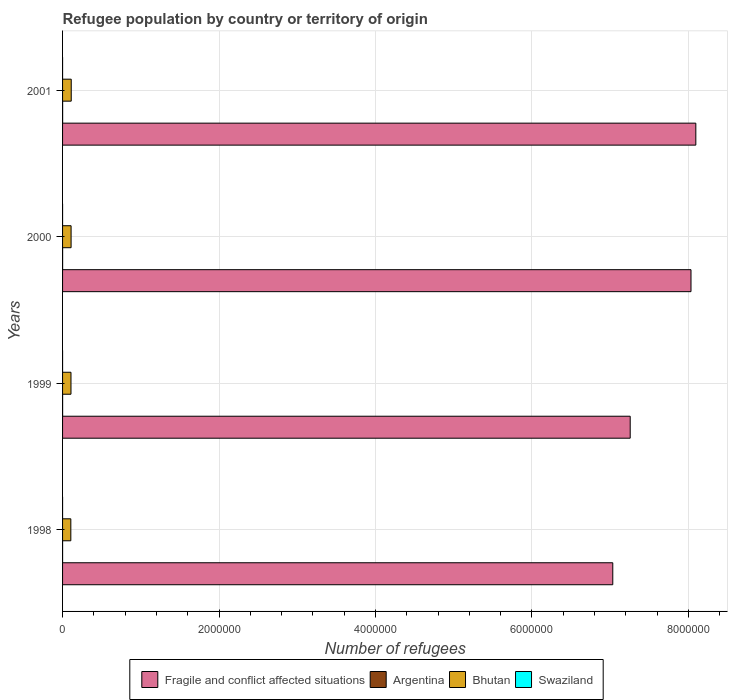How many different coloured bars are there?
Offer a very short reply. 4. Are the number of bars on each tick of the Y-axis equal?
Make the answer very short. Yes. How many bars are there on the 4th tick from the top?
Provide a short and direct response. 4. What is the label of the 4th group of bars from the top?
Make the answer very short. 1998. In how many cases, is the number of bars for a given year not equal to the number of legend labels?
Your answer should be compact. 0. What is the number of refugees in Fragile and conflict affected situations in 1998?
Offer a very short reply. 7.03e+06. Across all years, what is the maximum number of refugees in Bhutan?
Your response must be concise. 1.11e+05. Across all years, what is the minimum number of refugees in Argentina?
Keep it short and to the point. 142. In which year was the number of refugees in Argentina maximum?
Your response must be concise. 2001. In which year was the number of refugees in Argentina minimum?
Provide a short and direct response. 1998. What is the total number of refugees in Fragile and conflict affected situations in the graph?
Offer a terse response. 3.04e+07. What is the difference between the number of refugees in Argentina in 2000 and that in 2001?
Make the answer very short. -50. What is the difference between the number of refugees in Fragile and conflict affected situations in 2001 and the number of refugees in Argentina in 1999?
Ensure brevity in your answer.  8.09e+06. What is the average number of refugees in Bhutan per year?
Your answer should be very brief. 1.08e+05. In the year 1998, what is the difference between the number of refugees in Bhutan and number of refugees in Fragile and conflict affected situations?
Offer a terse response. -6.93e+06. In how many years, is the number of refugees in Argentina greater than 2000000 ?
Your response must be concise. 0. What is the ratio of the number of refugees in Argentina in 2000 to that in 2001?
Your answer should be compact. 0.92. Is the difference between the number of refugees in Bhutan in 1998 and 1999 greater than the difference between the number of refugees in Fragile and conflict affected situations in 1998 and 1999?
Offer a terse response. Yes. What is the difference between the highest and the second highest number of refugees in Swaziland?
Offer a terse response. 2. What is the difference between the highest and the lowest number of refugees in Bhutan?
Give a very brief answer. 5156. In how many years, is the number of refugees in Argentina greater than the average number of refugees in Argentina taken over all years?
Give a very brief answer. 3. What does the 4th bar from the top in 2000 represents?
Provide a short and direct response. Fragile and conflict affected situations. What does the 3rd bar from the bottom in 2001 represents?
Your answer should be compact. Bhutan. How many years are there in the graph?
Offer a very short reply. 4. Are the values on the major ticks of X-axis written in scientific E-notation?
Ensure brevity in your answer.  No. Does the graph contain grids?
Offer a very short reply. Yes. Where does the legend appear in the graph?
Provide a succinct answer. Bottom center. How are the legend labels stacked?
Ensure brevity in your answer.  Horizontal. What is the title of the graph?
Your response must be concise. Refugee population by country or territory of origin. What is the label or title of the X-axis?
Provide a succinct answer. Number of refugees. What is the label or title of the Y-axis?
Your answer should be very brief. Years. What is the Number of refugees of Fragile and conflict affected situations in 1998?
Provide a succinct answer. 7.03e+06. What is the Number of refugees in Argentina in 1998?
Your answer should be very brief. 142. What is the Number of refugees of Bhutan in 1998?
Keep it short and to the point. 1.06e+05. What is the Number of refugees of Fragile and conflict affected situations in 1999?
Your response must be concise. 7.26e+06. What is the Number of refugees in Argentina in 1999?
Provide a short and direct response. 586. What is the Number of refugees of Bhutan in 1999?
Make the answer very short. 1.08e+05. What is the Number of refugees of Fragile and conflict affected situations in 2000?
Your answer should be compact. 8.03e+06. What is the Number of refugees in Argentina in 2000?
Your answer should be compact. 609. What is the Number of refugees in Bhutan in 2000?
Offer a terse response. 1.09e+05. What is the Number of refugees in Fragile and conflict affected situations in 2001?
Offer a very short reply. 8.10e+06. What is the Number of refugees of Argentina in 2001?
Make the answer very short. 659. What is the Number of refugees in Bhutan in 2001?
Make the answer very short. 1.11e+05. What is the Number of refugees of Swaziland in 2001?
Your answer should be compact. 15. Across all years, what is the maximum Number of refugees in Fragile and conflict affected situations?
Your response must be concise. 8.10e+06. Across all years, what is the maximum Number of refugees of Argentina?
Provide a short and direct response. 659. Across all years, what is the maximum Number of refugees in Bhutan?
Your response must be concise. 1.11e+05. Across all years, what is the maximum Number of refugees in Swaziland?
Give a very brief answer. 30. Across all years, what is the minimum Number of refugees in Fragile and conflict affected situations?
Your answer should be compact. 7.03e+06. Across all years, what is the minimum Number of refugees of Argentina?
Your response must be concise. 142. Across all years, what is the minimum Number of refugees in Bhutan?
Provide a short and direct response. 1.06e+05. What is the total Number of refugees in Fragile and conflict affected situations in the graph?
Give a very brief answer. 3.04e+07. What is the total Number of refugees in Argentina in the graph?
Offer a terse response. 1996. What is the total Number of refugees of Bhutan in the graph?
Give a very brief answer. 4.33e+05. What is the total Number of refugees in Swaziland in the graph?
Your answer should be very brief. 89. What is the difference between the Number of refugees in Fragile and conflict affected situations in 1998 and that in 1999?
Make the answer very short. -2.23e+05. What is the difference between the Number of refugees in Argentina in 1998 and that in 1999?
Your answer should be compact. -444. What is the difference between the Number of refugees of Bhutan in 1998 and that in 1999?
Provide a succinct answer. -1930. What is the difference between the Number of refugees in Swaziland in 1998 and that in 1999?
Your answer should be compact. 2. What is the difference between the Number of refugees of Fragile and conflict affected situations in 1998 and that in 2000?
Provide a succinct answer. -1.00e+06. What is the difference between the Number of refugees in Argentina in 1998 and that in 2000?
Your answer should be very brief. -467. What is the difference between the Number of refugees in Bhutan in 1998 and that in 2000?
Provide a succinct answer. -3256. What is the difference between the Number of refugees of Fragile and conflict affected situations in 1998 and that in 2001?
Give a very brief answer. -1.06e+06. What is the difference between the Number of refugees in Argentina in 1998 and that in 2001?
Your answer should be compact. -517. What is the difference between the Number of refugees in Bhutan in 1998 and that in 2001?
Provide a short and direct response. -5156. What is the difference between the Number of refugees in Fragile and conflict affected situations in 1999 and that in 2000?
Keep it short and to the point. -7.77e+05. What is the difference between the Number of refugees in Argentina in 1999 and that in 2000?
Offer a very short reply. -23. What is the difference between the Number of refugees in Bhutan in 1999 and that in 2000?
Your answer should be compact. -1326. What is the difference between the Number of refugees in Fragile and conflict affected situations in 1999 and that in 2001?
Offer a terse response. -8.39e+05. What is the difference between the Number of refugees in Argentina in 1999 and that in 2001?
Your answer should be very brief. -73. What is the difference between the Number of refugees in Bhutan in 1999 and that in 2001?
Offer a terse response. -3226. What is the difference between the Number of refugees in Swaziland in 1999 and that in 2001?
Your response must be concise. 13. What is the difference between the Number of refugees in Fragile and conflict affected situations in 2000 and that in 2001?
Keep it short and to the point. -6.18e+04. What is the difference between the Number of refugees in Bhutan in 2000 and that in 2001?
Provide a short and direct response. -1900. What is the difference between the Number of refugees in Swaziland in 2000 and that in 2001?
Your response must be concise. 1. What is the difference between the Number of refugees in Fragile and conflict affected situations in 1998 and the Number of refugees in Argentina in 1999?
Your answer should be very brief. 7.03e+06. What is the difference between the Number of refugees in Fragile and conflict affected situations in 1998 and the Number of refugees in Bhutan in 1999?
Your answer should be compact. 6.93e+06. What is the difference between the Number of refugees in Fragile and conflict affected situations in 1998 and the Number of refugees in Swaziland in 1999?
Ensure brevity in your answer.  7.03e+06. What is the difference between the Number of refugees in Argentina in 1998 and the Number of refugees in Bhutan in 1999?
Your answer should be compact. -1.07e+05. What is the difference between the Number of refugees in Argentina in 1998 and the Number of refugees in Swaziland in 1999?
Ensure brevity in your answer.  114. What is the difference between the Number of refugees in Bhutan in 1998 and the Number of refugees in Swaziland in 1999?
Your answer should be very brief. 1.06e+05. What is the difference between the Number of refugees in Fragile and conflict affected situations in 1998 and the Number of refugees in Argentina in 2000?
Keep it short and to the point. 7.03e+06. What is the difference between the Number of refugees of Fragile and conflict affected situations in 1998 and the Number of refugees of Bhutan in 2000?
Provide a succinct answer. 6.92e+06. What is the difference between the Number of refugees in Fragile and conflict affected situations in 1998 and the Number of refugees in Swaziland in 2000?
Provide a succinct answer. 7.03e+06. What is the difference between the Number of refugees of Argentina in 1998 and the Number of refugees of Bhutan in 2000?
Offer a terse response. -1.09e+05. What is the difference between the Number of refugees of Argentina in 1998 and the Number of refugees of Swaziland in 2000?
Keep it short and to the point. 126. What is the difference between the Number of refugees in Bhutan in 1998 and the Number of refugees in Swaziland in 2000?
Offer a terse response. 1.06e+05. What is the difference between the Number of refugees in Fragile and conflict affected situations in 1998 and the Number of refugees in Argentina in 2001?
Your response must be concise. 7.03e+06. What is the difference between the Number of refugees of Fragile and conflict affected situations in 1998 and the Number of refugees of Bhutan in 2001?
Keep it short and to the point. 6.92e+06. What is the difference between the Number of refugees in Fragile and conflict affected situations in 1998 and the Number of refugees in Swaziland in 2001?
Ensure brevity in your answer.  7.03e+06. What is the difference between the Number of refugees of Argentina in 1998 and the Number of refugees of Bhutan in 2001?
Your answer should be compact. -1.11e+05. What is the difference between the Number of refugees of Argentina in 1998 and the Number of refugees of Swaziland in 2001?
Your answer should be compact. 127. What is the difference between the Number of refugees in Bhutan in 1998 and the Number of refugees in Swaziland in 2001?
Your response must be concise. 1.06e+05. What is the difference between the Number of refugees in Fragile and conflict affected situations in 1999 and the Number of refugees in Argentina in 2000?
Keep it short and to the point. 7.26e+06. What is the difference between the Number of refugees of Fragile and conflict affected situations in 1999 and the Number of refugees of Bhutan in 2000?
Provide a succinct answer. 7.15e+06. What is the difference between the Number of refugees of Fragile and conflict affected situations in 1999 and the Number of refugees of Swaziland in 2000?
Ensure brevity in your answer.  7.26e+06. What is the difference between the Number of refugees of Argentina in 1999 and the Number of refugees of Bhutan in 2000?
Give a very brief answer. -1.08e+05. What is the difference between the Number of refugees in Argentina in 1999 and the Number of refugees in Swaziland in 2000?
Provide a succinct answer. 570. What is the difference between the Number of refugees of Bhutan in 1999 and the Number of refugees of Swaziland in 2000?
Your answer should be compact. 1.08e+05. What is the difference between the Number of refugees of Fragile and conflict affected situations in 1999 and the Number of refugees of Argentina in 2001?
Give a very brief answer. 7.26e+06. What is the difference between the Number of refugees in Fragile and conflict affected situations in 1999 and the Number of refugees in Bhutan in 2001?
Offer a terse response. 7.15e+06. What is the difference between the Number of refugees of Fragile and conflict affected situations in 1999 and the Number of refugees of Swaziland in 2001?
Provide a succinct answer. 7.26e+06. What is the difference between the Number of refugees in Argentina in 1999 and the Number of refugees in Bhutan in 2001?
Your answer should be very brief. -1.10e+05. What is the difference between the Number of refugees in Argentina in 1999 and the Number of refugees in Swaziland in 2001?
Your response must be concise. 571. What is the difference between the Number of refugees of Bhutan in 1999 and the Number of refugees of Swaziland in 2001?
Make the answer very short. 1.08e+05. What is the difference between the Number of refugees in Fragile and conflict affected situations in 2000 and the Number of refugees in Argentina in 2001?
Make the answer very short. 8.03e+06. What is the difference between the Number of refugees in Fragile and conflict affected situations in 2000 and the Number of refugees in Bhutan in 2001?
Your response must be concise. 7.92e+06. What is the difference between the Number of refugees in Fragile and conflict affected situations in 2000 and the Number of refugees in Swaziland in 2001?
Offer a terse response. 8.03e+06. What is the difference between the Number of refugees in Argentina in 2000 and the Number of refugees in Bhutan in 2001?
Keep it short and to the point. -1.10e+05. What is the difference between the Number of refugees of Argentina in 2000 and the Number of refugees of Swaziland in 2001?
Ensure brevity in your answer.  594. What is the difference between the Number of refugees in Bhutan in 2000 and the Number of refugees in Swaziland in 2001?
Offer a very short reply. 1.09e+05. What is the average Number of refugees in Fragile and conflict affected situations per year?
Offer a very short reply. 7.60e+06. What is the average Number of refugees in Argentina per year?
Offer a very short reply. 499. What is the average Number of refugees of Bhutan per year?
Your answer should be compact. 1.08e+05. What is the average Number of refugees of Swaziland per year?
Ensure brevity in your answer.  22.25. In the year 1998, what is the difference between the Number of refugees in Fragile and conflict affected situations and Number of refugees in Argentina?
Make the answer very short. 7.03e+06. In the year 1998, what is the difference between the Number of refugees of Fragile and conflict affected situations and Number of refugees of Bhutan?
Your answer should be very brief. 6.93e+06. In the year 1998, what is the difference between the Number of refugees of Fragile and conflict affected situations and Number of refugees of Swaziland?
Provide a succinct answer. 7.03e+06. In the year 1998, what is the difference between the Number of refugees in Argentina and Number of refugees in Bhutan?
Offer a terse response. -1.06e+05. In the year 1998, what is the difference between the Number of refugees in Argentina and Number of refugees in Swaziland?
Provide a succinct answer. 112. In the year 1998, what is the difference between the Number of refugees of Bhutan and Number of refugees of Swaziland?
Ensure brevity in your answer.  1.06e+05. In the year 1999, what is the difference between the Number of refugees in Fragile and conflict affected situations and Number of refugees in Argentina?
Give a very brief answer. 7.26e+06. In the year 1999, what is the difference between the Number of refugees in Fragile and conflict affected situations and Number of refugees in Bhutan?
Give a very brief answer. 7.15e+06. In the year 1999, what is the difference between the Number of refugees of Fragile and conflict affected situations and Number of refugees of Swaziland?
Your response must be concise. 7.26e+06. In the year 1999, what is the difference between the Number of refugees in Argentina and Number of refugees in Bhutan?
Provide a short and direct response. -1.07e+05. In the year 1999, what is the difference between the Number of refugees of Argentina and Number of refugees of Swaziland?
Provide a short and direct response. 558. In the year 1999, what is the difference between the Number of refugees in Bhutan and Number of refugees in Swaziland?
Provide a succinct answer. 1.08e+05. In the year 2000, what is the difference between the Number of refugees in Fragile and conflict affected situations and Number of refugees in Argentina?
Make the answer very short. 8.03e+06. In the year 2000, what is the difference between the Number of refugees of Fragile and conflict affected situations and Number of refugees of Bhutan?
Your answer should be compact. 7.92e+06. In the year 2000, what is the difference between the Number of refugees in Fragile and conflict affected situations and Number of refugees in Swaziland?
Offer a very short reply. 8.03e+06. In the year 2000, what is the difference between the Number of refugees in Argentina and Number of refugees in Bhutan?
Provide a short and direct response. -1.08e+05. In the year 2000, what is the difference between the Number of refugees in Argentina and Number of refugees in Swaziland?
Offer a very short reply. 593. In the year 2000, what is the difference between the Number of refugees in Bhutan and Number of refugees in Swaziland?
Offer a very short reply. 1.09e+05. In the year 2001, what is the difference between the Number of refugees of Fragile and conflict affected situations and Number of refugees of Argentina?
Your response must be concise. 8.09e+06. In the year 2001, what is the difference between the Number of refugees in Fragile and conflict affected situations and Number of refugees in Bhutan?
Provide a short and direct response. 7.98e+06. In the year 2001, what is the difference between the Number of refugees of Fragile and conflict affected situations and Number of refugees of Swaziland?
Provide a succinct answer. 8.10e+06. In the year 2001, what is the difference between the Number of refugees of Argentina and Number of refugees of Bhutan?
Ensure brevity in your answer.  -1.10e+05. In the year 2001, what is the difference between the Number of refugees of Argentina and Number of refugees of Swaziland?
Give a very brief answer. 644. In the year 2001, what is the difference between the Number of refugees in Bhutan and Number of refugees in Swaziland?
Give a very brief answer. 1.11e+05. What is the ratio of the Number of refugees in Fragile and conflict affected situations in 1998 to that in 1999?
Your answer should be compact. 0.97. What is the ratio of the Number of refugees of Argentina in 1998 to that in 1999?
Give a very brief answer. 0.24. What is the ratio of the Number of refugees of Bhutan in 1998 to that in 1999?
Your answer should be very brief. 0.98. What is the ratio of the Number of refugees of Swaziland in 1998 to that in 1999?
Provide a short and direct response. 1.07. What is the ratio of the Number of refugees of Fragile and conflict affected situations in 1998 to that in 2000?
Your answer should be very brief. 0.88. What is the ratio of the Number of refugees in Argentina in 1998 to that in 2000?
Offer a very short reply. 0.23. What is the ratio of the Number of refugees in Bhutan in 1998 to that in 2000?
Provide a short and direct response. 0.97. What is the ratio of the Number of refugees in Swaziland in 1998 to that in 2000?
Offer a very short reply. 1.88. What is the ratio of the Number of refugees of Fragile and conflict affected situations in 1998 to that in 2001?
Your answer should be very brief. 0.87. What is the ratio of the Number of refugees in Argentina in 1998 to that in 2001?
Provide a short and direct response. 0.22. What is the ratio of the Number of refugees of Bhutan in 1998 to that in 2001?
Make the answer very short. 0.95. What is the ratio of the Number of refugees in Swaziland in 1998 to that in 2001?
Make the answer very short. 2. What is the ratio of the Number of refugees of Fragile and conflict affected situations in 1999 to that in 2000?
Provide a succinct answer. 0.9. What is the ratio of the Number of refugees in Argentina in 1999 to that in 2000?
Provide a succinct answer. 0.96. What is the ratio of the Number of refugees of Swaziland in 1999 to that in 2000?
Provide a short and direct response. 1.75. What is the ratio of the Number of refugees in Fragile and conflict affected situations in 1999 to that in 2001?
Your answer should be very brief. 0.9. What is the ratio of the Number of refugees in Argentina in 1999 to that in 2001?
Provide a succinct answer. 0.89. What is the ratio of the Number of refugees in Bhutan in 1999 to that in 2001?
Provide a succinct answer. 0.97. What is the ratio of the Number of refugees in Swaziland in 1999 to that in 2001?
Provide a succinct answer. 1.87. What is the ratio of the Number of refugees of Fragile and conflict affected situations in 2000 to that in 2001?
Your response must be concise. 0.99. What is the ratio of the Number of refugees of Argentina in 2000 to that in 2001?
Offer a very short reply. 0.92. What is the ratio of the Number of refugees of Bhutan in 2000 to that in 2001?
Provide a succinct answer. 0.98. What is the ratio of the Number of refugees of Swaziland in 2000 to that in 2001?
Your answer should be compact. 1.07. What is the difference between the highest and the second highest Number of refugees in Fragile and conflict affected situations?
Your response must be concise. 6.18e+04. What is the difference between the highest and the second highest Number of refugees of Argentina?
Offer a terse response. 50. What is the difference between the highest and the second highest Number of refugees of Bhutan?
Keep it short and to the point. 1900. What is the difference between the highest and the second highest Number of refugees of Swaziland?
Give a very brief answer. 2. What is the difference between the highest and the lowest Number of refugees in Fragile and conflict affected situations?
Keep it short and to the point. 1.06e+06. What is the difference between the highest and the lowest Number of refugees in Argentina?
Offer a terse response. 517. What is the difference between the highest and the lowest Number of refugees in Bhutan?
Your response must be concise. 5156. What is the difference between the highest and the lowest Number of refugees of Swaziland?
Provide a short and direct response. 15. 